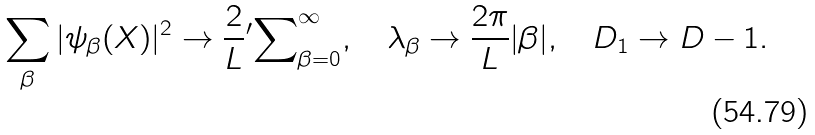<formula> <loc_0><loc_0><loc_500><loc_500>\sum _ { \beta } | \psi _ { \beta } ( X ) | ^ { 2 } \to \frac { 2 } { L } { ^ { \prime } } { \sum } _ { \beta = 0 } ^ { \infty } , \quad \lambda _ { \beta } \to \frac { 2 \pi } { L } | \beta | , \quad D _ { 1 } \to D - 1 .</formula> 